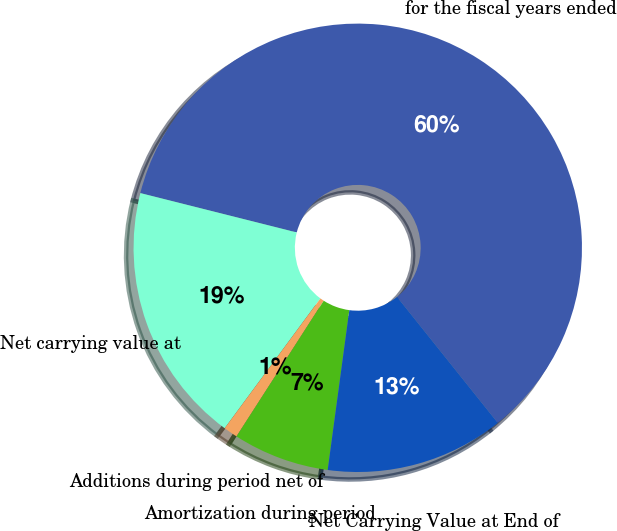Convert chart. <chart><loc_0><loc_0><loc_500><loc_500><pie_chart><fcel>for the fiscal years ended<fcel>Net carrying value at<fcel>Additions during period net of<fcel>Amortization during period<fcel>Net Carrying Value at End of<nl><fcel>60.33%<fcel>18.81%<fcel>1.02%<fcel>6.95%<fcel>12.88%<nl></chart> 